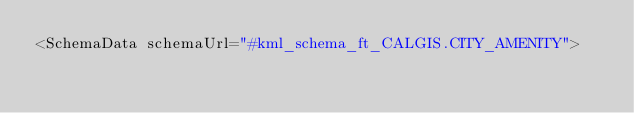Convert code to text. <code><loc_0><loc_0><loc_500><loc_500><_XML_><SchemaData schemaUrl="#kml_schema_ft_CALGIS.CITY_AMENITY"></code> 